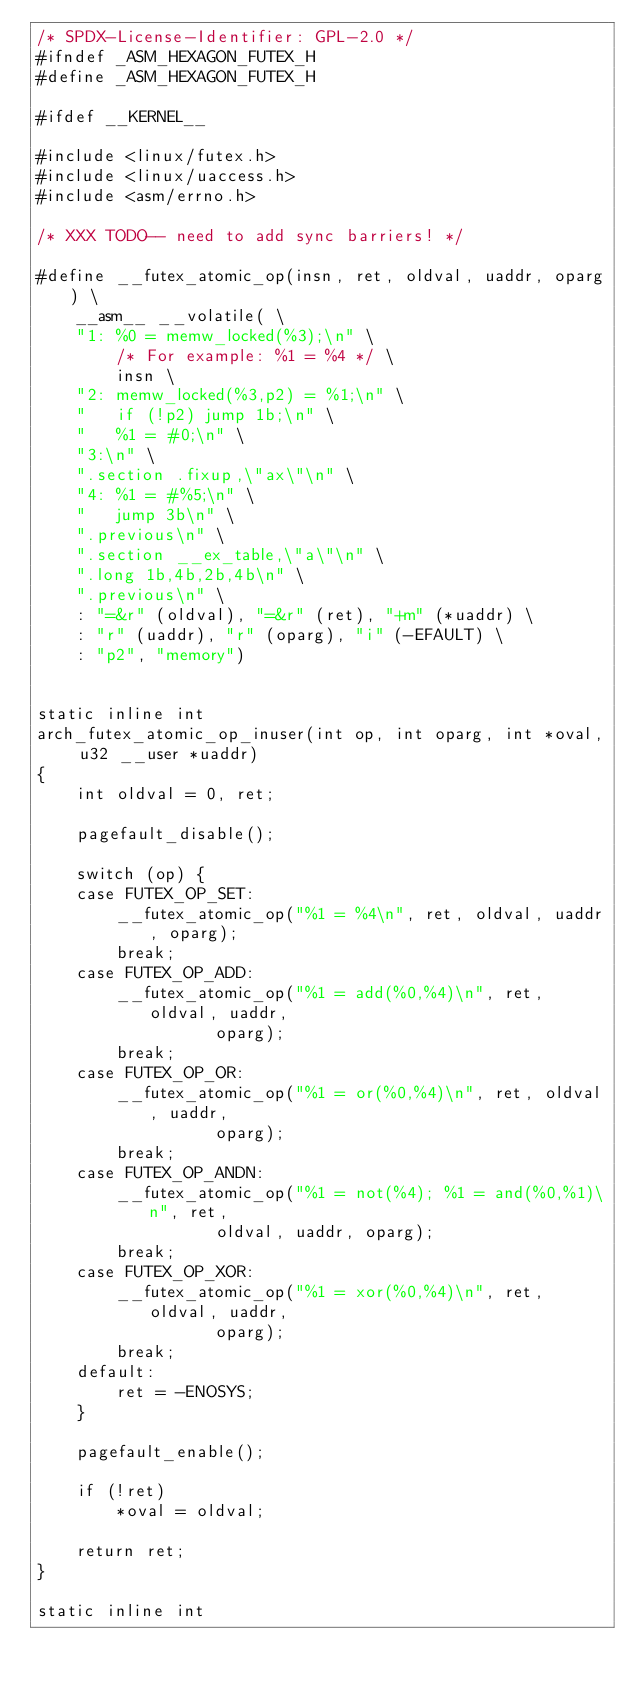Convert code to text. <code><loc_0><loc_0><loc_500><loc_500><_C_>/* SPDX-License-Identifier: GPL-2.0 */
#ifndef _ASM_HEXAGON_FUTEX_H
#define _ASM_HEXAGON_FUTEX_H

#ifdef __KERNEL__

#include <linux/futex.h>
#include <linux/uaccess.h>
#include <asm/errno.h>

/* XXX TODO-- need to add sync barriers! */

#define __futex_atomic_op(insn, ret, oldval, uaddr, oparg) \
	__asm__ __volatile( \
	"1: %0 = memw_locked(%3);\n" \
	    /* For example: %1 = %4 */ \
	    insn \
	"2: memw_locked(%3,p2) = %1;\n" \
	"   if (!p2) jump 1b;\n" \
	"   %1 = #0;\n" \
	"3:\n" \
	".section .fixup,\"ax\"\n" \
	"4: %1 = #%5;\n" \
	"   jump 3b\n" \
	".previous\n" \
	".section __ex_table,\"a\"\n" \
	".long 1b,4b,2b,4b\n" \
	".previous\n" \
	: "=&r" (oldval), "=&r" (ret), "+m" (*uaddr) \
	: "r" (uaddr), "r" (oparg), "i" (-EFAULT) \
	: "p2", "memory")


static inline int
arch_futex_atomic_op_inuser(int op, int oparg, int *oval, u32 __user *uaddr)
{
	int oldval = 0, ret;

	pagefault_disable();

	switch (op) {
	case FUTEX_OP_SET:
		__futex_atomic_op("%1 = %4\n", ret, oldval, uaddr, oparg);
		break;
	case FUTEX_OP_ADD:
		__futex_atomic_op("%1 = add(%0,%4)\n", ret, oldval, uaddr,
				  oparg);
		break;
	case FUTEX_OP_OR:
		__futex_atomic_op("%1 = or(%0,%4)\n", ret, oldval, uaddr,
				  oparg);
		break;
	case FUTEX_OP_ANDN:
		__futex_atomic_op("%1 = not(%4); %1 = and(%0,%1)\n", ret,
				  oldval, uaddr, oparg);
		break;
	case FUTEX_OP_XOR:
		__futex_atomic_op("%1 = xor(%0,%4)\n", ret, oldval, uaddr,
				  oparg);
		break;
	default:
		ret = -ENOSYS;
	}

	pagefault_enable();

	if (!ret)
		*oval = oldval;

	return ret;
}

static inline int</code> 